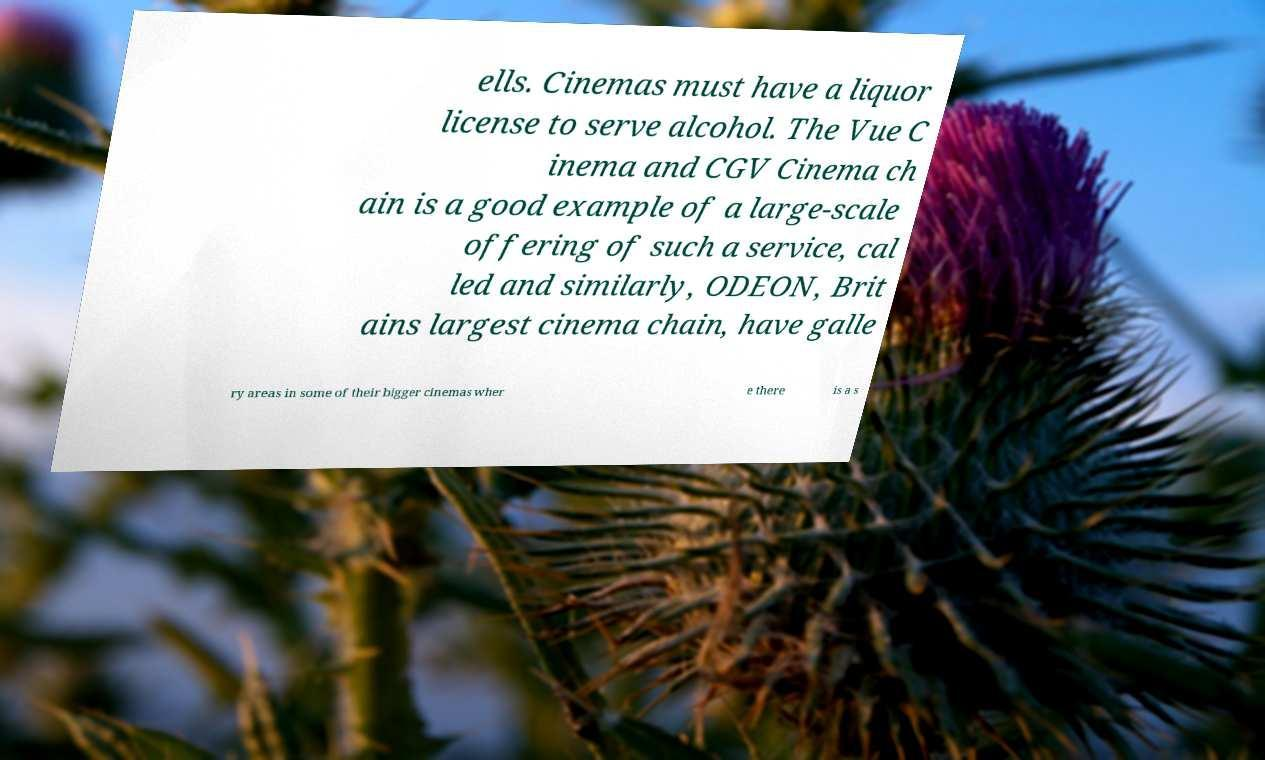Could you assist in decoding the text presented in this image and type it out clearly? ells. Cinemas must have a liquor license to serve alcohol. The Vue C inema and CGV Cinema ch ain is a good example of a large-scale offering of such a service, cal led and similarly, ODEON, Brit ains largest cinema chain, have galle ry areas in some of their bigger cinemas wher e there is a s 